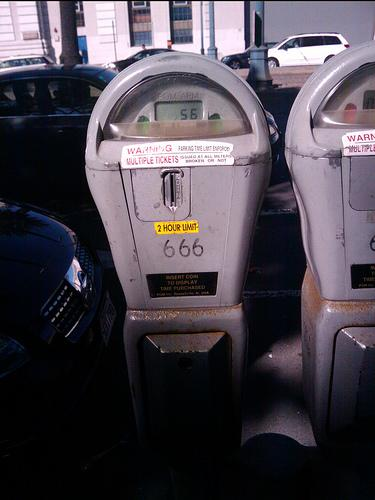Question: why was this photo taken?
Choices:
A. To show the number.
B. Because it is snowing.
C. Because the house is for sale.
D. To show the color.
Answer with the letter. Answer: A 